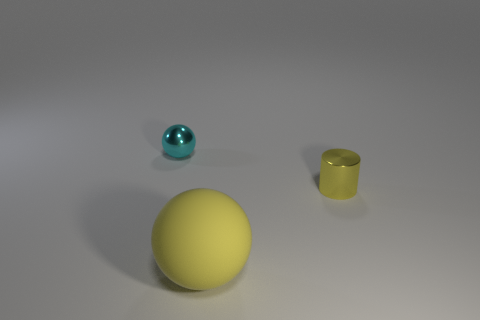Add 2 big yellow balls. How many objects exist? 5 Subtract 1 cylinders. How many cylinders are left? 0 Subtract all balls. How many objects are left? 1 Add 2 small things. How many small things exist? 4 Subtract 1 yellow cylinders. How many objects are left? 2 Subtract all cyan balls. Subtract all yellow blocks. How many balls are left? 1 Subtract all gray cylinders. How many cyan spheres are left? 1 Subtract all small cyan shiny things. Subtract all large yellow matte balls. How many objects are left? 1 Add 3 yellow matte objects. How many yellow matte objects are left? 4 